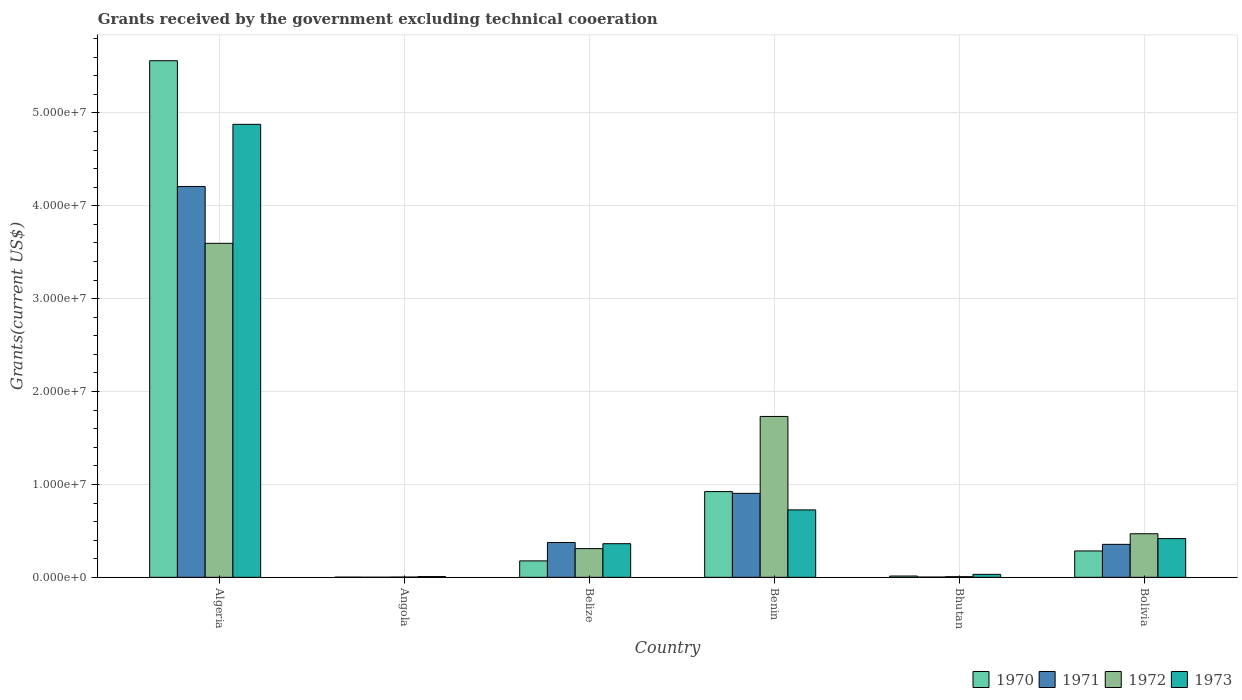Are the number of bars per tick equal to the number of legend labels?
Your answer should be compact. Yes. Are the number of bars on each tick of the X-axis equal?
Your response must be concise. Yes. What is the label of the 2nd group of bars from the left?
Offer a very short reply. Angola. In how many cases, is the number of bars for a given country not equal to the number of legend labels?
Make the answer very short. 0. What is the total grants received by the government in 1972 in Benin?
Offer a very short reply. 1.73e+07. Across all countries, what is the maximum total grants received by the government in 1971?
Make the answer very short. 4.21e+07. In which country was the total grants received by the government in 1970 maximum?
Offer a terse response. Algeria. In which country was the total grants received by the government in 1970 minimum?
Give a very brief answer. Angola. What is the total total grants received by the government in 1971 in the graph?
Keep it short and to the point. 5.85e+07. What is the difference between the total grants received by the government in 1973 in Algeria and that in Belize?
Your response must be concise. 4.52e+07. What is the difference between the total grants received by the government in 1973 in Belize and the total grants received by the government in 1970 in Angola?
Give a very brief answer. 3.60e+06. What is the average total grants received by the government in 1971 per country?
Provide a short and direct response. 9.74e+06. What is the difference between the total grants received by the government of/in 1973 and total grants received by the government of/in 1970 in Benin?
Offer a terse response. -1.97e+06. What is the ratio of the total grants received by the government in 1971 in Algeria to that in Angola?
Keep it short and to the point. 4208. Is the difference between the total grants received by the government in 1973 in Algeria and Bolivia greater than the difference between the total grants received by the government in 1970 in Algeria and Bolivia?
Give a very brief answer. No. What is the difference between the highest and the second highest total grants received by the government in 1971?
Offer a terse response. 3.83e+07. What is the difference between the highest and the lowest total grants received by the government in 1971?
Your answer should be very brief. 4.21e+07. In how many countries, is the total grants received by the government in 1970 greater than the average total grants received by the government in 1970 taken over all countries?
Ensure brevity in your answer.  1. Is the sum of the total grants received by the government in 1972 in Algeria and Belize greater than the maximum total grants received by the government in 1970 across all countries?
Offer a terse response. No. Is it the case that in every country, the sum of the total grants received by the government in 1971 and total grants received by the government in 1970 is greater than the sum of total grants received by the government in 1973 and total grants received by the government in 1972?
Your answer should be very brief. No. What does the 3rd bar from the left in Bhutan represents?
Your answer should be compact. 1972. How many bars are there?
Provide a succinct answer. 24. Are all the bars in the graph horizontal?
Offer a very short reply. No. How many countries are there in the graph?
Your response must be concise. 6. Does the graph contain any zero values?
Your answer should be very brief. No. Does the graph contain grids?
Give a very brief answer. Yes. How are the legend labels stacked?
Offer a terse response. Horizontal. What is the title of the graph?
Provide a short and direct response. Grants received by the government excluding technical cooeration. Does "1995" appear as one of the legend labels in the graph?
Make the answer very short. No. What is the label or title of the X-axis?
Keep it short and to the point. Country. What is the label or title of the Y-axis?
Offer a terse response. Grants(current US$). What is the Grants(current US$) of 1970 in Algeria?
Make the answer very short. 5.56e+07. What is the Grants(current US$) in 1971 in Algeria?
Ensure brevity in your answer.  4.21e+07. What is the Grants(current US$) of 1972 in Algeria?
Keep it short and to the point. 3.60e+07. What is the Grants(current US$) in 1973 in Algeria?
Ensure brevity in your answer.  4.88e+07. What is the Grants(current US$) of 1971 in Angola?
Your answer should be very brief. 10000. What is the Grants(current US$) in 1972 in Angola?
Your answer should be compact. 3.00e+04. What is the Grants(current US$) in 1970 in Belize?
Provide a short and direct response. 1.77e+06. What is the Grants(current US$) of 1971 in Belize?
Your answer should be very brief. 3.75e+06. What is the Grants(current US$) in 1972 in Belize?
Your answer should be very brief. 3.09e+06. What is the Grants(current US$) of 1973 in Belize?
Provide a succinct answer. 3.62e+06. What is the Grants(current US$) of 1970 in Benin?
Keep it short and to the point. 9.23e+06. What is the Grants(current US$) of 1971 in Benin?
Keep it short and to the point. 9.04e+06. What is the Grants(current US$) in 1972 in Benin?
Offer a terse response. 1.73e+07. What is the Grants(current US$) of 1973 in Benin?
Provide a succinct answer. 7.26e+06. What is the Grants(current US$) of 1970 in Bhutan?
Your response must be concise. 1.40e+05. What is the Grants(current US$) in 1971 in Bhutan?
Ensure brevity in your answer.  3.00e+04. What is the Grants(current US$) of 1972 in Bhutan?
Make the answer very short. 7.00e+04. What is the Grants(current US$) of 1970 in Bolivia?
Provide a succinct answer. 2.84e+06. What is the Grants(current US$) of 1971 in Bolivia?
Your answer should be compact. 3.55e+06. What is the Grants(current US$) in 1972 in Bolivia?
Provide a short and direct response. 4.69e+06. What is the Grants(current US$) of 1973 in Bolivia?
Ensure brevity in your answer.  4.17e+06. Across all countries, what is the maximum Grants(current US$) of 1970?
Your response must be concise. 5.56e+07. Across all countries, what is the maximum Grants(current US$) in 1971?
Your response must be concise. 4.21e+07. Across all countries, what is the maximum Grants(current US$) of 1972?
Ensure brevity in your answer.  3.60e+07. Across all countries, what is the maximum Grants(current US$) in 1973?
Your response must be concise. 4.88e+07. Across all countries, what is the minimum Grants(current US$) of 1970?
Your response must be concise. 2.00e+04. Across all countries, what is the minimum Grants(current US$) in 1973?
Provide a short and direct response. 8.00e+04. What is the total Grants(current US$) in 1970 in the graph?
Your answer should be compact. 6.96e+07. What is the total Grants(current US$) in 1971 in the graph?
Your answer should be very brief. 5.85e+07. What is the total Grants(current US$) in 1972 in the graph?
Your answer should be very brief. 6.12e+07. What is the total Grants(current US$) of 1973 in the graph?
Provide a short and direct response. 6.42e+07. What is the difference between the Grants(current US$) in 1970 in Algeria and that in Angola?
Give a very brief answer. 5.56e+07. What is the difference between the Grants(current US$) in 1971 in Algeria and that in Angola?
Offer a very short reply. 4.21e+07. What is the difference between the Grants(current US$) in 1972 in Algeria and that in Angola?
Make the answer very short. 3.59e+07. What is the difference between the Grants(current US$) in 1973 in Algeria and that in Angola?
Give a very brief answer. 4.87e+07. What is the difference between the Grants(current US$) of 1970 in Algeria and that in Belize?
Offer a very short reply. 5.38e+07. What is the difference between the Grants(current US$) in 1971 in Algeria and that in Belize?
Offer a terse response. 3.83e+07. What is the difference between the Grants(current US$) of 1972 in Algeria and that in Belize?
Provide a short and direct response. 3.29e+07. What is the difference between the Grants(current US$) in 1973 in Algeria and that in Belize?
Offer a terse response. 4.52e+07. What is the difference between the Grants(current US$) in 1970 in Algeria and that in Benin?
Your response must be concise. 4.64e+07. What is the difference between the Grants(current US$) in 1971 in Algeria and that in Benin?
Offer a terse response. 3.30e+07. What is the difference between the Grants(current US$) of 1972 in Algeria and that in Benin?
Provide a succinct answer. 1.86e+07. What is the difference between the Grants(current US$) of 1973 in Algeria and that in Benin?
Provide a succinct answer. 4.15e+07. What is the difference between the Grants(current US$) in 1970 in Algeria and that in Bhutan?
Your answer should be very brief. 5.55e+07. What is the difference between the Grants(current US$) in 1971 in Algeria and that in Bhutan?
Ensure brevity in your answer.  4.20e+07. What is the difference between the Grants(current US$) in 1972 in Algeria and that in Bhutan?
Ensure brevity in your answer.  3.59e+07. What is the difference between the Grants(current US$) in 1973 in Algeria and that in Bhutan?
Your answer should be very brief. 4.84e+07. What is the difference between the Grants(current US$) of 1970 in Algeria and that in Bolivia?
Your answer should be very brief. 5.28e+07. What is the difference between the Grants(current US$) of 1971 in Algeria and that in Bolivia?
Provide a succinct answer. 3.85e+07. What is the difference between the Grants(current US$) of 1972 in Algeria and that in Bolivia?
Make the answer very short. 3.13e+07. What is the difference between the Grants(current US$) of 1973 in Algeria and that in Bolivia?
Ensure brevity in your answer.  4.46e+07. What is the difference between the Grants(current US$) in 1970 in Angola and that in Belize?
Your response must be concise. -1.75e+06. What is the difference between the Grants(current US$) in 1971 in Angola and that in Belize?
Offer a terse response. -3.74e+06. What is the difference between the Grants(current US$) in 1972 in Angola and that in Belize?
Your answer should be very brief. -3.06e+06. What is the difference between the Grants(current US$) of 1973 in Angola and that in Belize?
Provide a succinct answer. -3.54e+06. What is the difference between the Grants(current US$) of 1970 in Angola and that in Benin?
Offer a terse response. -9.21e+06. What is the difference between the Grants(current US$) in 1971 in Angola and that in Benin?
Provide a short and direct response. -9.03e+06. What is the difference between the Grants(current US$) in 1972 in Angola and that in Benin?
Keep it short and to the point. -1.73e+07. What is the difference between the Grants(current US$) in 1973 in Angola and that in Benin?
Your answer should be compact. -7.18e+06. What is the difference between the Grants(current US$) in 1972 in Angola and that in Bhutan?
Provide a succinct answer. -4.00e+04. What is the difference between the Grants(current US$) of 1970 in Angola and that in Bolivia?
Make the answer very short. -2.82e+06. What is the difference between the Grants(current US$) of 1971 in Angola and that in Bolivia?
Your answer should be very brief. -3.54e+06. What is the difference between the Grants(current US$) in 1972 in Angola and that in Bolivia?
Give a very brief answer. -4.66e+06. What is the difference between the Grants(current US$) of 1973 in Angola and that in Bolivia?
Your response must be concise. -4.09e+06. What is the difference between the Grants(current US$) in 1970 in Belize and that in Benin?
Provide a succinct answer. -7.46e+06. What is the difference between the Grants(current US$) in 1971 in Belize and that in Benin?
Provide a short and direct response. -5.29e+06. What is the difference between the Grants(current US$) in 1972 in Belize and that in Benin?
Your answer should be compact. -1.42e+07. What is the difference between the Grants(current US$) of 1973 in Belize and that in Benin?
Your answer should be compact. -3.64e+06. What is the difference between the Grants(current US$) of 1970 in Belize and that in Bhutan?
Provide a short and direct response. 1.63e+06. What is the difference between the Grants(current US$) of 1971 in Belize and that in Bhutan?
Your response must be concise. 3.72e+06. What is the difference between the Grants(current US$) of 1972 in Belize and that in Bhutan?
Your answer should be very brief. 3.02e+06. What is the difference between the Grants(current US$) of 1973 in Belize and that in Bhutan?
Your answer should be very brief. 3.30e+06. What is the difference between the Grants(current US$) in 1970 in Belize and that in Bolivia?
Make the answer very short. -1.07e+06. What is the difference between the Grants(current US$) of 1972 in Belize and that in Bolivia?
Make the answer very short. -1.60e+06. What is the difference between the Grants(current US$) of 1973 in Belize and that in Bolivia?
Provide a short and direct response. -5.50e+05. What is the difference between the Grants(current US$) in 1970 in Benin and that in Bhutan?
Your answer should be very brief. 9.09e+06. What is the difference between the Grants(current US$) of 1971 in Benin and that in Bhutan?
Your answer should be very brief. 9.01e+06. What is the difference between the Grants(current US$) of 1972 in Benin and that in Bhutan?
Provide a succinct answer. 1.72e+07. What is the difference between the Grants(current US$) of 1973 in Benin and that in Bhutan?
Offer a very short reply. 6.94e+06. What is the difference between the Grants(current US$) in 1970 in Benin and that in Bolivia?
Offer a terse response. 6.39e+06. What is the difference between the Grants(current US$) in 1971 in Benin and that in Bolivia?
Provide a short and direct response. 5.49e+06. What is the difference between the Grants(current US$) of 1972 in Benin and that in Bolivia?
Your response must be concise. 1.26e+07. What is the difference between the Grants(current US$) of 1973 in Benin and that in Bolivia?
Give a very brief answer. 3.09e+06. What is the difference between the Grants(current US$) in 1970 in Bhutan and that in Bolivia?
Your answer should be very brief. -2.70e+06. What is the difference between the Grants(current US$) in 1971 in Bhutan and that in Bolivia?
Provide a short and direct response. -3.52e+06. What is the difference between the Grants(current US$) of 1972 in Bhutan and that in Bolivia?
Offer a very short reply. -4.62e+06. What is the difference between the Grants(current US$) of 1973 in Bhutan and that in Bolivia?
Offer a terse response. -3.85e+06. What is the difference between the Grants(current US$) of 1970 in Algeria and the Grants(current US$) of 1971 in Angola?
Give a very brief answer. 5.56e+07. What is the difference between the Grants(current US$) of 1970 in Algeria and the Grants(current US$) of 1972 in Angola?
Offer a very short reply. 5.56e+07. What is the difference between the Grants(current US$) in 1970 in Algeria and the Grants(current US$) in 1973 in Angola?
Provide a short and direct response. 5.55e+07. What is the difference between the Grants(current US$) of 1971 in Algeria and the Grants(current US$) of 1972 in Angola?
Offer a very short reply. 4.20e+07. What is the difference between the Grants(current US$) of 1971 in Algeria and the Grants(current US$) of 1973 in Angola?
Provide a short and direct response. 4.20e+07. What is the difference between the Grants(current US$) of 1972 in Algeria and the Grants(current US$) of 1973 in Angola?
Provide a short and direct response. 3.59e+07. What is the difference between the Grants(current US$) of 1970 in Algeria and the Grants(current US$) of 1971 in Belize?
Offer a very short reply. 5.19e+07. What is the difference between the Grants(current US$) in 1970 in Algeria and the Grants(current US$) in 1972 in Belize?
Offer a very short reply. 5.25e+07. What is the difference between the Grants(current US$) of 1970 in Algeria and the Grants(current US$) of 1973 in Belize?
Your answer should be compact. 5.20e+07. What is the difference between the Grants(current US$) of 1971 in Algeria and the Grants(current US$) of 1972 in Belize?
Offer a terse response. 3.90e+07. What is the difference between the Grants(current US$) in 1971 in Algeria and the Grants(current US$) in 1973 in Belize?
Provide a short and direct response. 3.85e+07. What is the difference between the Grants(current US$) of 1972 in Algeria and the Grants(current US$) of 1973 in Belize?
Provide a short and direct response. 3.23e+07. What is the difference between the Grants(current US$) in 1970 in Algeria and the Grants(current US$) in 1971 in Benin?
Your answer should be compact. 4.66e+07. What is the difference between the Grants(current US$) in 1970 in Algeria and the Grants(current US$) in 1972 in Benin?
Keep it short and to the point. 3.83e+07. What is the difference between the Grants(current US$) in 1970 in Algeria and the Grants(current US$) in 1973 in Benin?
Keep it short and to the point. 4.84e+07. What is the difference between the Grants(current US$) of 1971 in Algeria and the Grants(current US$) of 1972 in Benin?
Make the answer very short. 2.48e+07. What is the difference between the Grants(current US$) of 1971 in Algeria and the Grants(current US$) of 1973 in Benin?
Your answer should be very brief. 3.48e+07. What is the difference between the Grants(current US$) in 1972 in Algeria and the Grants(current US$) in 1973 in Benin?
Your response must be concise. 2.87e+07. What is the difference between the Grants(current US$) of 1970 in Algeria and the Grants(current US$) of 1971 in Bhutan?
Provide a succinct answer. 5.56e+07. What is the difference between the Grants(current US$) in 1970 in Algeria and the Grants(current US$) in 1972 in Bhutan?
Provide a succinct answer. 5.56e+07. What is the difference between the Grants(current US$) of 1970 in Algeria and the Grants(current US$) of 1973 in Bhutan?
Provide a short and direct response. 5.53e+07. What is the difference between the Grants(current US$) in 1971 in Algeria and the Grants(current US$) in 1972 in Bhutan?
Provide a short and direct response. 4.20e+07. What is the difference between the Grants(current US$) of 1971 in Algeria and the Grants(current US$) of 1973 in Bhutan?
Ensure brevity in your answer.  4.18e+07. What is the difference between the Grants(current US$) of 1972 in Algeria and the Grants(current US$) of 1973 in Bhutan?
Keep it short and to the point. 3.56e+07. What is the difference between the Grants(current US$) in 1970 in Algeria and the Grants(current US$) in 1971 in Bolivia?
Make the answer very short. 5.21e+07. What is the difference between the Grants(current US$) in 1970 in Algeria and the Grants(current US$) in 1972 in Bolivia?
Give a very brief answer. 5.09e+07. What is the difference between the Grants(current US$) in 1970 in Algeria and the Grants(current US$) in 1973 in Bolivia?
Ensure brevity in your answer.  5.14e+07. What is the difference between the Grants(current US$) of 1971 in Algeria and the Grants(current US$) of 1972 in Bolivia?
Ensure brevity in your answer.  3.74e+07. What is the difference between the Grants(current US$) in 1971 in Algeria and the Grants(current US$) in 1973 in Bolivia?
Offer a very short reply. 3.79e+07. What is the difference between the Grants(current US$) in 1972 in Algeria and the Grants(current US$) in 1973 in Bolivia?
Your response must be concise. 3.18e+07. What is the difference between the Grants(current US$) in 1970 in Angola and the Grants(current US$) in 1971 in Belize?
Provide a succinct answer. -3.73e+06. What is the difference between the Grants(current US$) of 1970 in Angola and the Grants(current US$) of 1972 in Belize?
Your answer should be very brief. -3.07e+06. What is the difference between the Grants(current US$) in 1970 in Angola and the Grants(current US$) in 1973 in Belize?
Offer a terse response. -3.60e+06. What is the difference between the Grants(current US$) in 1971 in Angola and the Grants(current US$) in 1972 in Belize?
Make the answer very short. -3.08e+06. What is the difference between the Grants(current US$) of 1971 in Angola and the Grants(current US$) of 1973 in Belize?
Offer a very short reply. -3.61e+06. What is the difference between the Grants(current US$) of 1972 in Angola and the Grants(current US$) of 1973 in Belize?
Offer a very short reply. -3.59e+06. What is the difference between the Grants(current US$) in 1970 in Angola and the Grants(current US$) in 1971 in Benin?
Give a very brief answer. -9.02e+06. What is the difference between the Grants(current US$) in 1970 in Angola and the Grants(current US$) in 1972 in Benin?
Keep it short and to the point. -1.73e+07. What is the difference between the Grants(current US$) of 1970 in Angola and the Grants(current US$) of 1973 in Benin?
Make the answer very short. -7.24e+06. What is the difference between the Grants(current US$) of 1971 in Angola and the Grants(current US$) of 1972 in Benin?
Give a very brief answer. -1.73e+07. What is the difference between the Grants(current US$) of 1971 in Angola and the Grants(current US$) of 1973 in Benin?
Offer a very short reply. -7.25e+06. What is the difference between the Grants(current US$) in 1972 in Angola and the Grants(current US$) in 1973 in Benin?
Ensure brevity in your answer.  -7.23e+06. What is the difference between the Grants(current US$) in 1971 in Angola and the Grants(current US$) in 1973 in Bhutan?
Your answer should be compact. -3.10e+05. What is the difference between the Grants(current US$) of 1972 in Angola and the Grants(current US$) of 1973 in Bhutan?
Make the answer very short. -2.90e+05. What is the difference between the Grants(current US$) of 1970 in Angola and the Grants(current US$) of 1971 in Bolivia?
Your answer should be compact. -3.53e+06. What is the difference between the Grants(current US$) of 1970 in Angola and the Grants(current US$) of 1972 in Bolivia?
Provide a succinct answer. -4.67e+06. What is the difference between the Grants(current US$) in 1970 in Angola and the Grants(current US$) in 1973 in Bolivia?
Offer a very short reply. -4.15e+06. What is the difference between the Grants(current US$) in 1971 in Angola and the Grants(current US$) in 1972 in Bolivia?
Offer a terse response. -4.68e+06. What is the difference between the Grants(current US$) of 1971 in Angola and the Grants(current US$) of 1973 in Bolivia?
Provide a short and direct response. -4.16e+06. What is the difference between the Grants(current US$) in 1972 in Angola and the Grants(current US$) in 1973 in Bolivia?
Ensure brevity in your answer.  -4.14e+06. What is the difference between the Grants(current US$) of 1970 in Belize and the Grants(current US$) of 1971 in Benin?
Your answer should be very brief. -7.27e+06. What is the difference between the Grants(current US$) of 1970 in Belize and the Grants(current US$) of 1972 in Benin?
Keep it short and to the point. -1.56e+07. What is the difference between the Grants(current US$) of 1970 in Belize and the Grants(current US$) of 1973 in Benin?
Your answer should be compact. -5.49e+06. What is the difference between the Grants(current US$) in 1971 in Belize and the Grants(current US$) in 1972 in Benin?
Your answer should be very brief. -1.36e+07. What is the difference between the Grants(current US$) of 1971 in Belize and the Grants(current US$) of 1973 in Benin?
Your answer should be compact. -3.51e+06. What is the difference between the Grants(current US$) in 1972 in Belize and the Grants(current US$) in 1973 in Benin?
Your answer should be compact. -4.17e+06. What is the difference between the Grants(current US$) of 1970 in Belize and the Grants(current US$) of 1971 in Bhutan?
Offer a very short reply. 1.74e+06. What is the difference between the Grants(current US$) in 1970 in Belize and the Grants(current US$) in 1972 in Bhutan?
Offer a very short reply. 1.70e+06. What is the difference between the Grants(current US$) of 1970 in Belize and the Grants(current US$) of 1973 in Bhutan?
Keep it short and to the point. 1.45e+06. What is the difference between the Grants(current US$) of 1971 in Belize and the Grants(current US$) of 1972 in Bhutan?
Ensure brevity in your answer.  3.68e+06. What is the difference between the Grants(current US$) in 1971 in Belize and the Grants(current US$) in 1973 in Bhutan?
Your answer should be compact. 3.43e+06. What is the difference between the Grants(current US$) of 1972 in Belize and the Grants(current US$) of 1973 in Bhutan?
Make the answer very short. 2.77e+06. What is the difference between the Grants(current US$) of 1970 in Belize and the Grants(current US$) of 1971 in Bolivia?
Ensure brevity in your answer.  -1.78e+06. What is the difference between the Grants(current US$) in 1970 in Belize and the Grants(current US$) in 1972 in Bolivia?
Your response must be concise. -2.92e+06. What is the difference between the Grants(current US$) in 1970 in Belize and the Grants(current US$) in 1973 in Bolivia?
Provide a succinct answer. -2.40e+06. What is the difference between the Grants(current US$) of 1971 in Belize and the Grants(current US$) of 1972 in Bolivia?
Make the answer very short. -9.40e+05. What is the difference between the Grants(current US$) of 1971 in Belize and the Grants(current US$) of 1973 in Bolivia?
Your answer should be very brief. -4.20e+05. What is the difference between the Grants(current US$) of 1972 in Belize and the Grants(current US$) of 1973 in Bolivia?
Make the answer very short. -1.08e+06. What is the difference between the Grants(current US$) of 1970 in Benin and the Grants(current US$) of 1971 in Bhutan?
Make the answer very short. 9.20e+06. What is the difference between the Grants(current US$) in 1970 in Benin and the Grants(current US$) in 1972 in Bhutan?
Your answer should be compact. 9.16e+06. What is the difference between the Grants(current US$) in 1970 in Benin and the Grants(current US$) in 1973 in Bhutan?
Make the answer very short. 8.91e+06. What is the difference between the Grants(current US$) of 1971 in Benin and the Grants(current US$) of 1972 in Bhutan?
Ensure brevity in your answer.  8.97e+06. What is the difference between the Grants(current US$) of 1971 in Benin and the Grants(current US$) of 1973 in Bhutan?
Your response must be concise. 8.72e+06. What is the difference between the Grants(current US$) of 1972 in Benin and the Grants(current US$) of 1973 in Bhutan?
Offer a terse response. 1.70e+07. What is the difference between the Grants(current US$) of 1970 in Benin and the Grants(current US$) of 1971 in Bolivia?
Make the answer very short. 5.68e+06. What is the difference between the Grants(current US$) of 1970 in Benin and the Grants(current US$) of 1972 in Bolivia?
Provide a short and direct response. 4.54e+06. What is the difference between the Grants(current US$) in 1970 in Benin and the Grants(current US$) in 1973 in Bolivia?
Offer a very short reply. 5.06e+06. What is the difference between the Grants(current US$) of 1971 in Benin and the Grants(current US$) of 1972 in Bolivia?
Provide a short and direct response. 4.35e+06. What is the difference between the Grants(current US$) in 1971 in Benin and the Grants(current US$) in 1973 in Bolivia?
Offer a terse response. 4.87e+06. What is the difference between the Grants(current US$) in 1972 in Benin and the Grants(current US$) in 1973 in Bolivia?
Provide a short and direct response. 1.32e+07. What is the difference between the Grants(current US$) in 1970 in Bhutan and the Grants(current US$) in 1971 in Bolivia?
Your answer should be compact. -3.41e+06. What is the difference between the Grants(current US$) of 1970 in Bhutan and the Grants(current US$) of 1972 in Bolivia?
Offer a terse response. -4.55e+06. What is the difference between the Grants(current US$) in 1970 in Bhutan and the Grants(current US$) in 1973 in Bolivia?
Your answer should be very brief. -4.03e+06. What is the difference between the Grants(current US$) of 1971 in Bhutan and the Grants(current US$) of 1972 in Bolivia?
Ensure brevity in your answer.  -4.66e+06. What is the difference between the Grants(current US$) in 1971 in Bhutan and the Grants(current US$) in 1973 in Bolivia?
Your response must be concise. -4.14e+06. What is the difference between the Grants(current US$) of 1972 in Bhutan and the Grants(current US$) of 1973 in Bolivia?
Your response must be concise. -4.10e+06. What is the average Grants(current US$) of 1970 per country?
Provide a short and direct response. 1.16e+07. What is the average Grants(current US$) of 1971 per country?
Offer a terse response. 9.74e+06. What is the average Grants(current US$) in 1972 per country?
Your answer should be very brief. 1.02e+07. What is the average Grants(current US$) in 1973 per country?
Make the answer very short. 1.07e+07. What is the difference between the Grants(current US$) in 1970 and Grants(current US$) in 1971 in Algeria?
Keep it short and to the point. 1.35e+07. What is the difference between the Grants(current US$) in 1970 and Grants(current US$) in 1972 in Algeria?
Keep it short and to the point. 1.97e+07. What is the difference between the Grants(current US$) in 1970 and Grants(current US$) in 1973 in Algeria?
Your answer should be very brief. 6.85e+06. What is the difference between the Grants(current US$) of 1971 and Grants(current US$) of 1972 in Algeria?
Offer a terse response. 6.12e+06. What is the difference between the Grants(current US$) of 1971 and Grants(current US$) of 1973 in Algeria?
Your response must be concise. -6.69e+06. What is the difference between the Grants(current US$) in 1972 and Grants(current US$) in 1973 in Algeria?
Make the answer very short. -1.28e+07. What is the difference between the Grants(current US$) of 1970 and Grants(current US$) of 1971 in Angola?
Your response must be concise. 10000. What is the difference between the Grants(current US$) of 1970 and Grants(current US$) of 1971 in Belize?
Your answer should be very brief. -1.98e+06. What is the difference between the Grants(current US$) of 1970 and Grants(current US$) of 1972 in Belize?
Your response must be concise. -1.32e+06. What is the difference between the Grants(current US$) of 1970 and Grants(current US$) of 1973 in Belize?
Offer a very short reply. -1.85e+06. What is the difference between the Grants(current US$) of 1971 and Grants(current US$) of 1972 in Belize?
Ensure brevity in your answer.  6.60e+05. What is the difference between the Grants(current US$) in 1971 and Grants(current US$) in 1973 in Belize?
Offer a terse response. 1.30e+05. What is the difference between the Grants(current US$) of 1972 and Grants(current US$) of 1973 in Belize?
Make the answer very short. -5.30e+05. What is the difference between the Grants(current US$) in 1970 and Grants(current US$) in 1971 in Benin?
Your response must be concise. 1.90e+05. What is the difference between the Grants(current US$) in 1970 and Grants(current US$) in 1972 in Benin?
Offer a very short reply. -8.09e+06. What is the difference between the Grants(current US$) in 1970 and Grants(current US$) in 1973 in Benin?
Offer a very short reply. 1.97e+06. What is the difference between the Grants(current US$) of 1971 and Grants(current US$) of 1972 in Benin?
Ensure brevity in your answer.  -8.28e+06. What is the difference between the Grants(current US$) of 1971 and Grants(current US$) of 1973 in Benin?
Make the answer very short. 1.78e+06. What is the difference between the Grants(current US$) of 1972 and Grants(current US$) of 1973 in Benin?
Your answer should be very brief. 1.01e+07. What is the difference between the Grants(current US$) in 1971 and Grants(current US$) in 1972 in Bhutan?
Your response must be concise. -4.00e+04. What is the difference between the Grants(current US$) in 1972 and Grants(current US$) in 1973 in Bhutan?
Make the answer very short. -2.50e+05. What is the difference between the Grants(current US$) in 1970 and Grants(current US$) in 1971 in Bolivia?
Your response must be concise. -7.10e+05. What is the difference between the Grants(current US$) in 1970 and Grants(current US$) in 1972 in Bolivia?
Keep it short and to the point. -1.85e+06. What is the difference between the Grants(current US$) in 1970 and Grants(current US$) in 1973 in Bolivia?
Your answer should be compact. -1.33e+06. What is the difference between the Grants(current US$) in 1971 and Grants(current US$) in 1972 in Bolivia?
Your response must be concise. -1.14e+06. What is the difference between the Grants(current US$) of 1971 and Grants(current US$) of 1973 in Bolivia?
Ensure brevity in your answer.  -6.20e+05. What is the difference between the Grants(current US$) in 1972 and Grants(current US$) in 1973 in Bolivia?
Your response must be concise. 5.20e+05. What is the ratio of the Grants(current US$) in 1970 in Algeria to that in Angola?
Keep it short and to the point. 2781. What is the ratio of the Grants(current US$) in 1971 in Algeria to that in Angola?
Your response must be concise. 4208. What is the ratio of the Grants(current US$) of 1972 in Algeria to that in Angola?
Provide a succinct answer. 1198.67. What is the ratio of the Grants(current US$) of 1973 in Algeria to that in Angola?
Your response must be concise. 609.62. What is the ratio of the Grants(current US$) in 1970 in Algeria to that in Belize?
Your answer should be very brief. 31.42. What is the ratio of the Grants(current US$) in 1971 in Algeria to that in Belize?
Keep it short and to the point. 11.22. What is the ratio of the Grants(current US$) in 1972 in Algeria to that in Belize?
Make the answer very short. 11.64. What is the ratio of the Grants(current US$) in 1973 in Algeria to that in Belize?
Make the answer very short. 13.47. What is the ratio of the Grants(current US$) of 1970 in Algeria to that in Benin?
Ensure brevity in your answer.  6.03. What is the ratio of the Grants(current US$) in 1971 in Algeria to that in Benin?
Your answer should be very brief. 4.65. What is the ratio of the Grants(current US$) in 1972 in Algeria to that in Benin?
Your response must be concise. 2.08. What is the ratio of the Grants(current US$) of 1973 in Algeria to that in Benin?
Ensure brevity in your answer.  6.72. What is the ratio of the Grants(current US$) in 1970 in Algeria to that in Bhutan?
Keep it short and to the point. 397.29. What is the ratio of the Grants(current US$) in 1971 in Algeria to that in Bhutan?
Keep it short and to the point. 1402.67. What is the ratio of the Grants(current US$) in 1972 in Algeria to that in Bhutan?
Ensure brevity in your answer.  513.71. What is the ratio of the Grants(current US$) of 1973 in Algeria to that in Bhutan?
Your response must be concise. 152.41. What is the ratio of the Grants(current US$) in 1970 in Algeria to that in Bolivia?
Your answer should be very brief. 19.58. What is the ratio of the Grants(current US$) of 1971 in Algeria to that in Bolivia?
Ensure brevity in your answer.  11.85. What is the ratio of the Grants(current US$) of 1972 in Algeria to that in Bolivia?
Give a very brief answer. 7.67. What is the ratio of the Grants(current US$) in 1973 in Algeria to that in Bolivia?
Provide a succinct answer. 11.7. What is the ratio of the Grants(current US$) of 1970 in Angola to that in Belize?
Provide a short and direct response. 0.01. What is the ratio of the Grants(current US$) in 1971 in Angola to that in Belize?
Provide a succinct answer. 0. What is the ratio of the Grants(current US$) in 1972 in Angola to that in Belize?
Offer a terse response. 0.01. What is the ratio of the Grants(current US$) in 1973 in Angola to that in Belize?
Offer a terse response. 0.02. What is the ratio of the Grants(current US$) in 1970 in Angola to that in Benin?
Your answer should be compact. 0. What is the ratio of the Grants(current US$) of 1971 in Angola to that in Benin?
Offer a terse response. 0. What is the ratio of the Grants(current US$) in 1972 in Angola to that in Benin?
Your answer should be very brief. 0. What is the ratio of the Grants(current US$) in 1973 in Angola to that in Benin?
Offer a very short reply. 0.01. What is the ratio of the Grants(current US$) of 1970 in Angola to that in Bhutan?
Ensure brevity in your answer.  0.14. What is the ratio of the Grants(current US$) in 1971 in Angola to that in Bhutan?
Your answer should be compact. 0.33. What is the ratio of the Grants(current US$) of 1972 in Angola to that in Bhutan?
Keep it short and to the point. 0.43. What is the ratio of the Grants(current US$) in 1973 in Angola to that in Bhutan?
Provide a short and direct response. 0.25. What is the ratio of the Grants(current US$) of 1970 in Angola to that in Bolivia?
Provide a short and direct response. 0.01. What is the ratio of the Grants(current US$) in 1971 in Angola to that in Bolivia?
Your answer should be compact. 0. What is the ratio of the Grants(current US$) in 1972 in Angola to that in Bolivia?
Provide a short and direct response. 0.01. What is the ratio of the Grants(current US$) in 1973 in Angola to that in Bolivia?
Provide a succinct answer. 0.02. What is the ratio of the Grants(current US$) in 1970 in Belize to that in Benin?
Your answer should be very brief. 0.19. What is the ratio of the Grants(current US$) of 1971 in Belize to that in Benin?
Your answer should be compact. 0.41. What is the ratio of the Grants(current US$) in 1972 in Belize to that in Benin?
Ensure brevity in your answer.  0.18. What is the ratio of the Grants(current US$) in 1973 in Belize to that in Benin?
Offer a terse response. 0.5. What is the ratio of the Grants(current US$) of 1970 in Belize to that in Bhutan?
Ensure brevity in your answer.  12.64. What is the ratio of the Grants(current US$) in 1971 in Belize to that in Bhutan?
Your response must be concise. 125. What is the ratio of the Grants(current US$) in 1972 in Belize to that in Bhutan?
Your response must be concise. 44.14. What is the ratio of the Grants(current US$) in 1973 in Belize to that in Bhutan?
Provide a succinct answer. 11.31. What is the ratio of the Grants(current US$) in 1970 in Belize to that in Bolivia?
Offer a terse response. 0.62. What is the ratio of the Grants(current US$) in 1971 in Belize to that in Bolivia?
Your answer should be very brief. 1.06. What is the ratio of the Grants(current US$) in 1972 in Belize to that in Bolivia?
Your answer should be compact. 0.66. What is the ratio of the Grants(current US$) in 1973 in Belize to that in Bolivia?
Your answer should be compact. 0.87. What is the ratio of the Grants(current US$) of 1970 in Benin to that in Bhutan?
Give a very brief answer. 65.93. What is the ratio of the Grants(current US$) in 1971 in Benin to that in Bhutan?
Your answer should be compact. 301.33. What is the ratio of the Grants(current US$) of 1972 in Benin to that in Bhutan?
Give a very brief answer. 247.43. What is the ratio of the Grants(current US$) in 1973 in Benin to that in Bhutan?
Your answer should be compact. 22.69. What is the ratio of the Grants(current US$) in 1971 in Benin to that in Bolivia?
Keep it short and to the point. 2.55. What is the ratio of the Grants(current US$) of 1972 in Benin to that in Bolivia?
Offer a very short reply. 3.69. What is the ratio of the Grants(current US$) in 1973 in Benin to that in Bolivia?
Provide a short and direct response. 1.74. What is the ratio of the Grants(current US$) of 1970 in Bhutan to that in Bolivia?
Ensure brevity in your answer.  0.05. What is the ratio of the Grants(current US$) in 1971 in Bhutan to that in Bolivia?
Provide a succinct answer. 0.01. What is the ratio of the Grants(current US$) of 1972 in Bhutan to that in Bolivia?
Your answer should be compact. 0.01. What is the ratio of the Grants(current US$) in 1973 in Bhutan to that in Bolivia?
Provide a short and direct response. 0.08. What is the difference between the highest and the second highest Grants(current US$) of 1970?
Make the answer very short. 4.64e+07. What is the difference between the highest and the second highest Grants(current US$) in 1971?
Your response must be concise. 3.30e+07. What is the difference between the highest and the second highest Grants(current US$) of 1972?
Your answer should be very brief. 1.86e+07. What is the difference between the highest and the second highest Grants(current US$) in 1973?
Ensure brevity in your answer.  4.15e+07. What is the difference between the highest and the lowest Grants(current US$) of 1970?
Your response must be concise. 5.56e+07. What is the difference between the highest and the lowest Grants(current US$) in 1971?
Offer a terse response. 4.21e+07. What is the difference between the highest and the lowest Grants(current US$) in 1972?
Offer a terse response. 3.59e+07. What is the difference between the highest and the lowest Grants(current US$) of 1973?
Make the answer very short. 4.87e+07. 